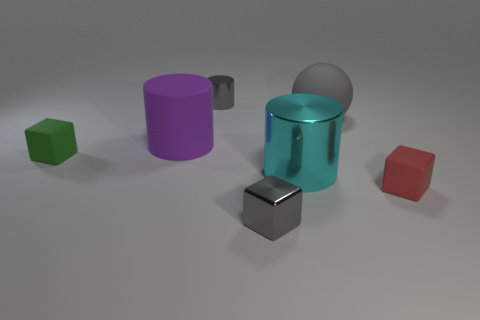What number of tiny metallic cylinders are the same color as the tiny metal cube?
Your answer should be very brief. 1. Are there any gray metallic cylinders that are in front of the cylinder that is left of the tiny cylinder?
Give a very brief answer. No. Are the green block and the tiny gray block made of the same material?
Ensure brevity in your answer.  No. There is a rubber thing that is both left of the red rubber object and on the right side of the purple cylinder; what shape is it?
Ensure brevity in your answer.  Sphere. There is a metal object that is behind the matte block that is to the left of the large matte sphere; what is its size?
Offer a terse response. Small. How many gray things have the same shape as the large purple thing?
Make the answer very short. 1. Do the big rubber ball and the tiny cylinder have the same color?
Provide a succinct answer. Yes. Is there any other thing that is the same shape as the small red matte object?
Provide a succinct answer. Yes. Is there a large cylinder of the same color as the big sphere?
Your response must be concise. No. Does the big object in front of the purple matte thing have the same material as the gray object in front of the big matte cylinder?
Give a very brief answer. Yes. 